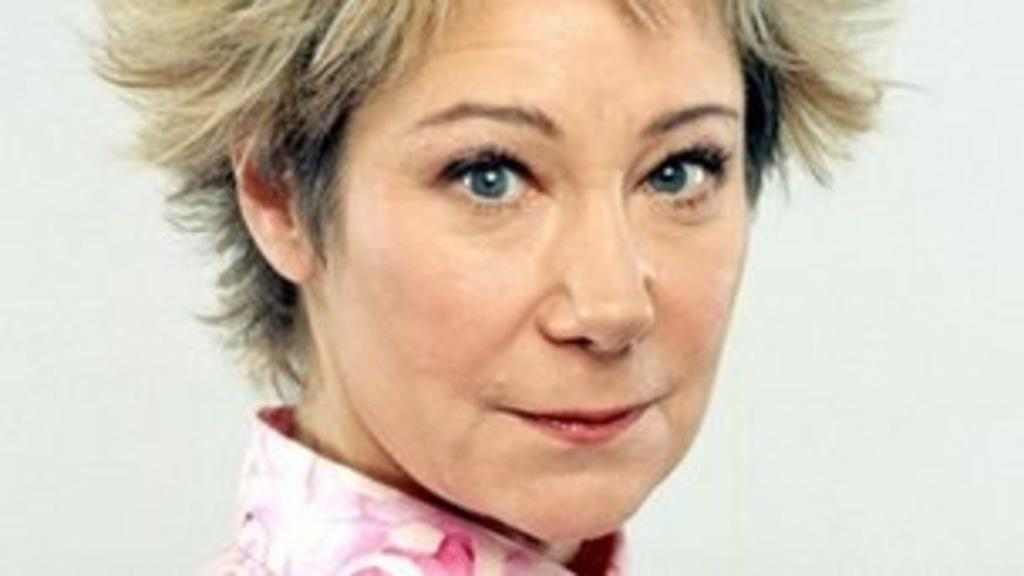Who or what is the main subject in the image? There is a person in the image. What can be observed about the background of the image? The background of the image is white. Is there a sign indicating a rainstorm in the image? There is no sign or indication of a rainstorm in the image. How many people are present in the image? The image only shows one person, so there is no group present. 